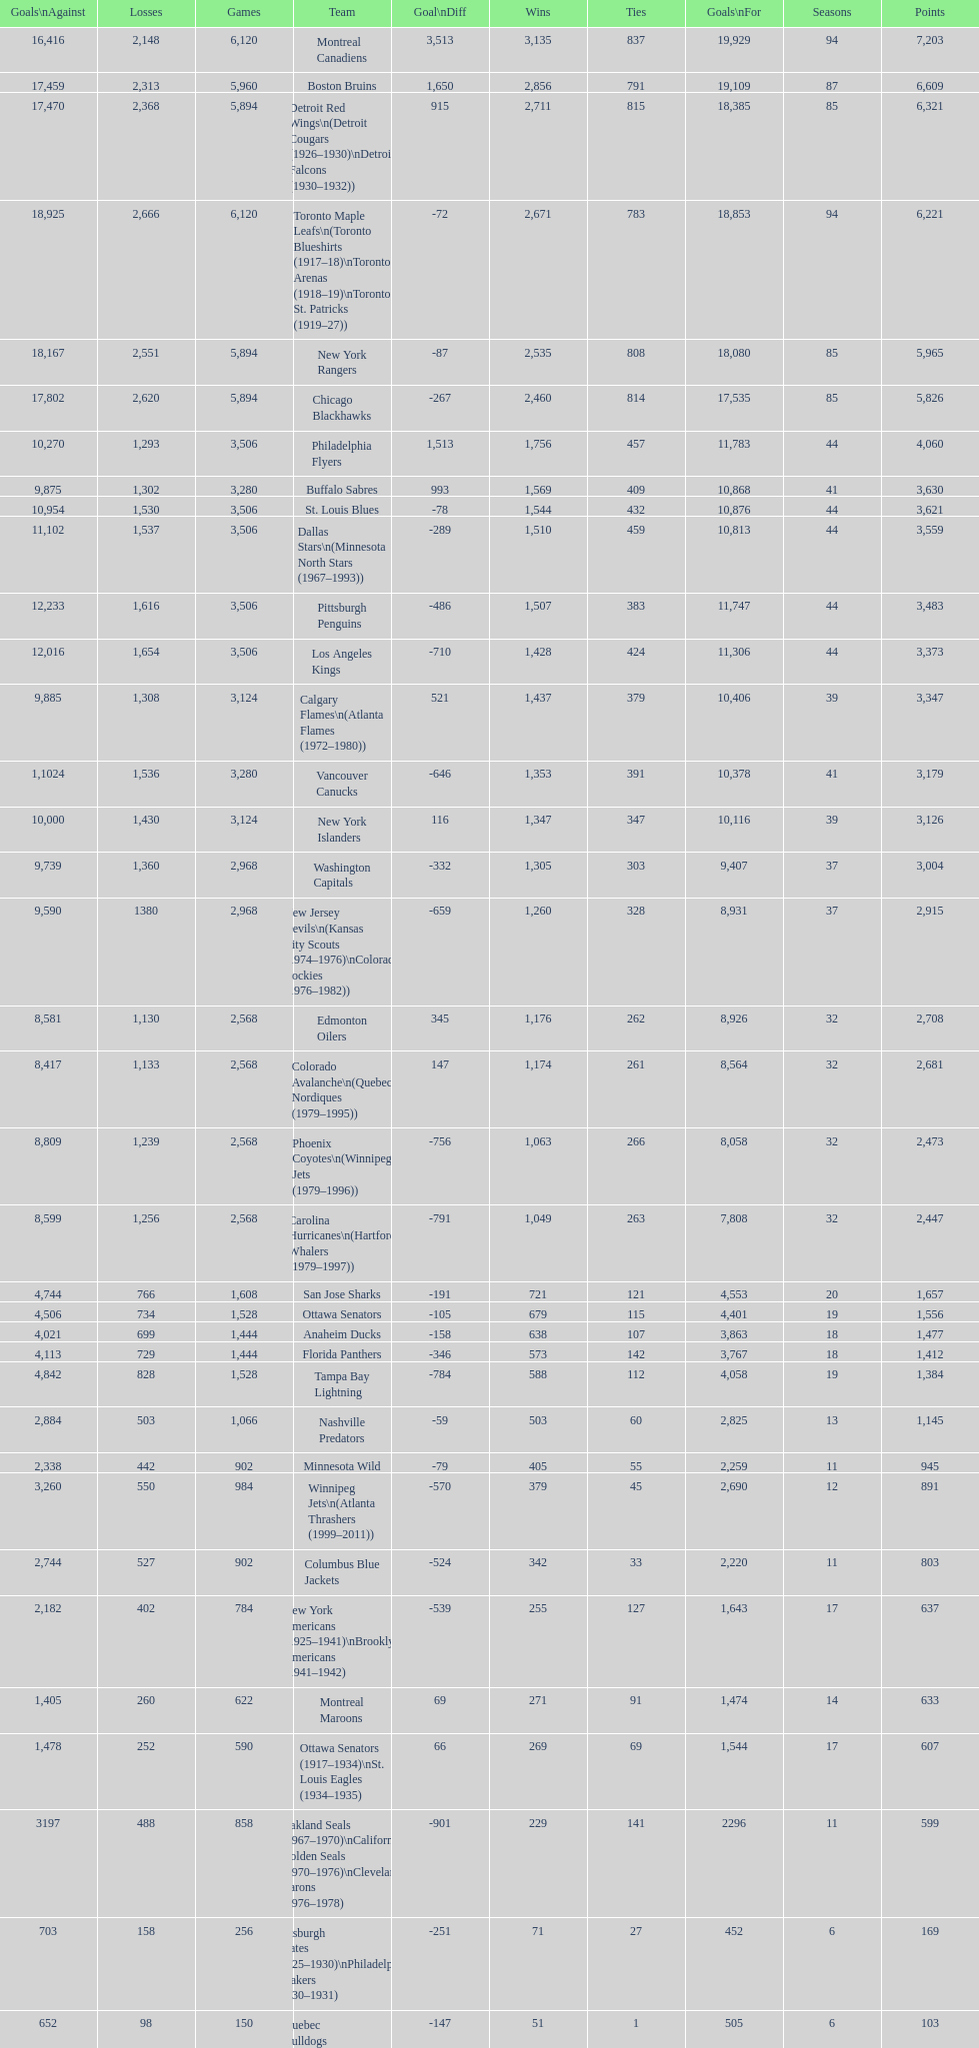Who has the least amount of losses? Montreal Wanderers. 